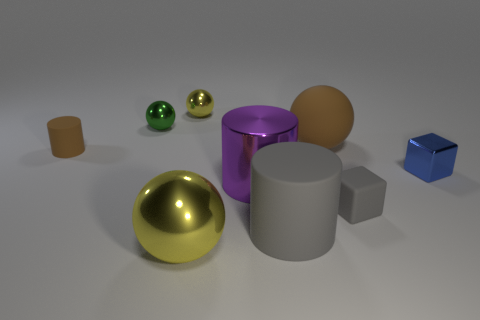Is the number of green spheres behind the tiny gray matte cube greater than the number of shiny things?
Provide a succinct answer. No. What number of small metal objects are right of the tiny sphere in front of the yellow object that is behind the green object?
Offer a terse response. 2. There is a brown rubber object behind the brown cylinder; is its size the same as the yellow sphere behind the brown matte ball?
Ensure brevity in your answer.  No. The yellow ball that is behind the small matte object that is in front of the big metallic cylinder is made of what material?
Make the answer very short. Metal. How many things are matte objects that are to the left of the small green shiny thing or yellow objects?
Your answer should be compact. 3. Are there an equal number of brown things that are to the right of the small yellow sphere and gray cylinders to the left of the big yellow ball?
Offer a terse response. No. What is the material of the cylinder that is in front of the tiny matte object on the right side of the yellow metallic object in front of the big brown sphere?
Keep it short and to the point. Rubber. What is the size of the matte object that is both to the right of the big yellow metallic object and behind the purple shiny cylinder?
Your answer should be very brief. Large. Is the tiny blue metal thing the same shape as the tiny green metal thing?
Offer a terse response. No. What is the shape of the large gray object that is the same material as the tiny brown thing?
Provide a succinct answer. Cylinder. 